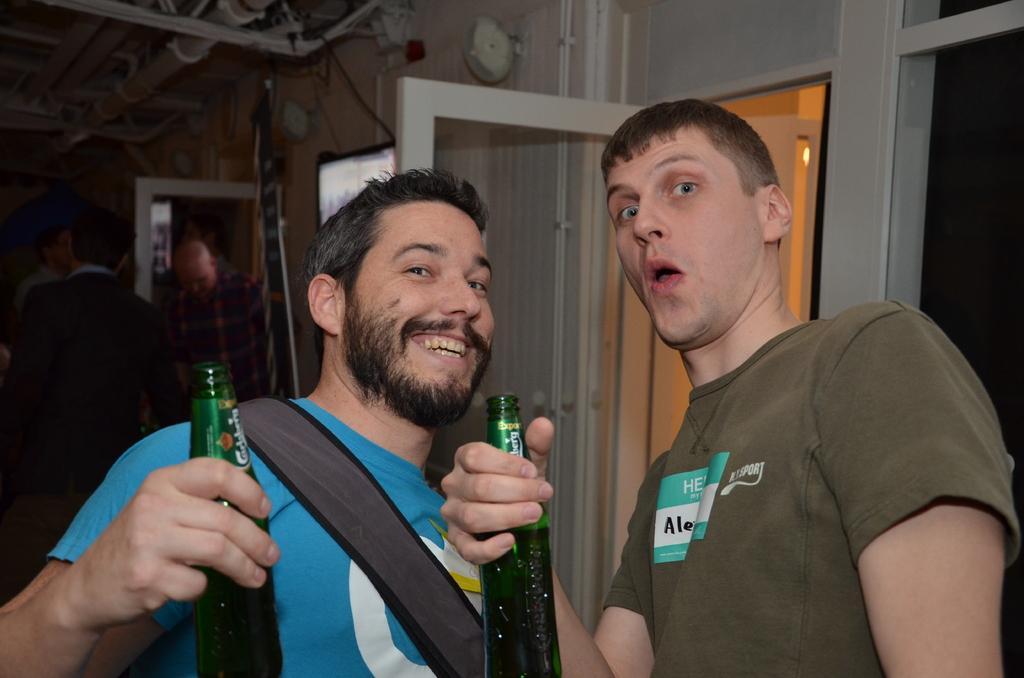Can you describe this image briefly? On the right side a man is looking at this side. He wore t-shirt, on the left side another man wore blue color t-shirt and also holding the beer in his right hand. He is smiling too. 